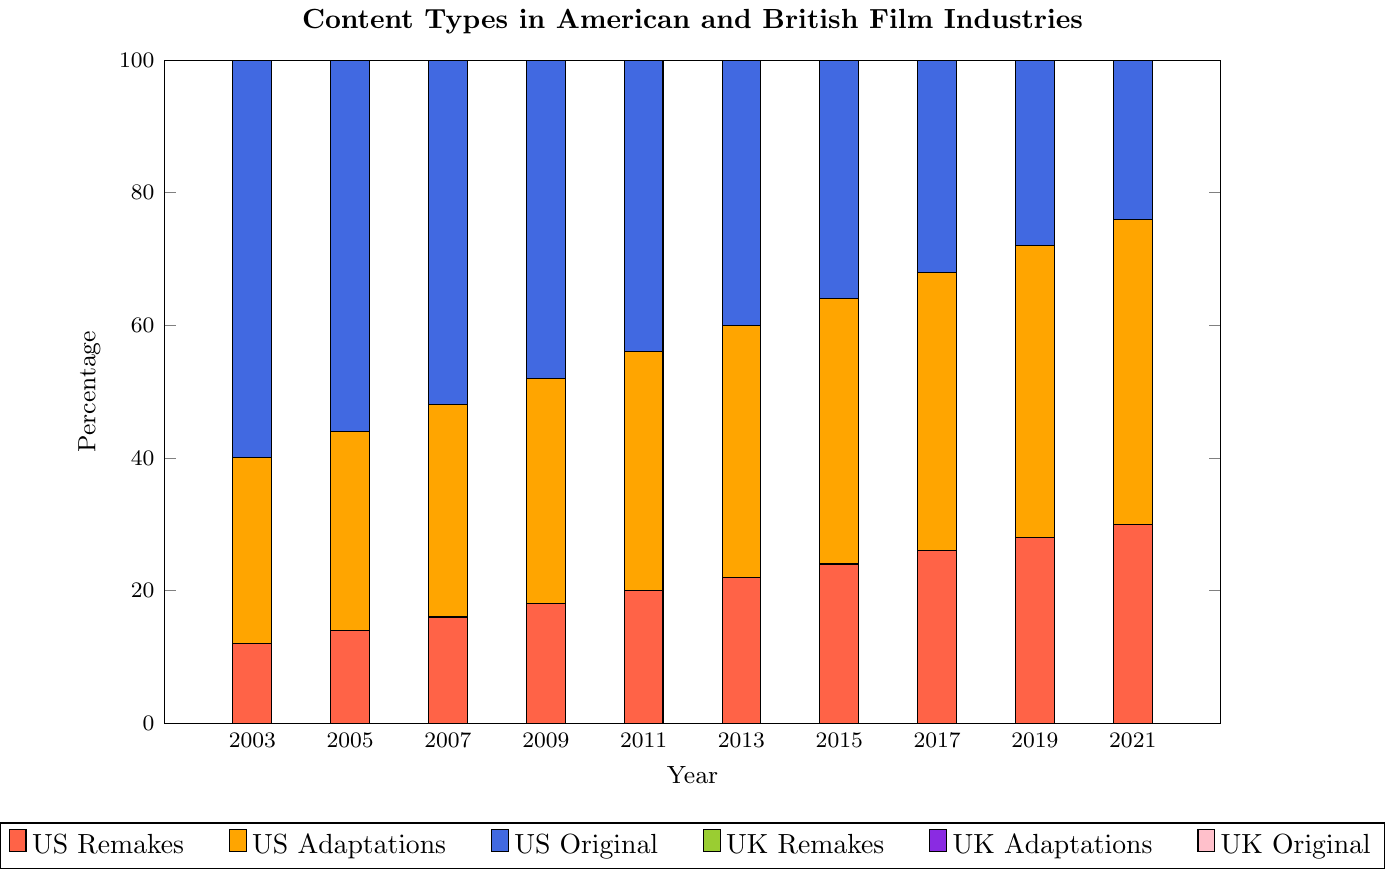What trend do you observe in the percentage of original content in the US film industry from 2003 to 2021? The percentage of original content in the US film industry shows a declining trend from 60% in 2003 to 24% in 2021. This indicates that US films are increasingly becoming adaptations or remakes over the years.
Answer: Declining trend from 60% to 24% How does the percentage of remakes in the UK film industry in 2021 compare to that in 2003? To compare the percentage of remakes in the UK film industry, observe that it is 8% in 2003 and 17% in 2021. This shows an increase in the percentage of remakes over the years.
Answer: Increased from 8% to 17% In which year did the US have the highest percentage of adaptations, and what was the percentage? To find the year with the highest percentage of adaptations for the US, we look at the years 2003 to 2021. The percentage of adaptations increases to a maximum of 46% in 2021.
Answer: 2021, 46% Compare the percentages of original content in the UK and the US film industries in 2013. In 2013, the percentage of original content in the US film industry is 40%, and in the UK, it is 55%. Thus, the UK has a higher percentage of original content than the US in that year.
Answer: UK: 55%, US: 40% What is the total percentage of remakes and adaptations combined in the UK film industry in 2017? To find the total percentage of remakes and adaptations in the UK film industry in 2017, add the percentages: remakes (15%) + adaptations (36%) = 51%.
Answer: 51% Is there a year where the percentage of remakes is equal in both the US and UK film industries? By comparing each year from 2003 to 2021, there is no year where the percentage of remakes is the same for both the US and UK film industries.
Answer: No By how much did the percentage of US original content decrease from 2003 to 2019? Calculate the difference in percentage of original content for the US from 2003 (60%) to 2019 (28%). The decrease is 60% - 28% = 32%.
Answer: 32% Which type of content (remakes, adaptations, or original) has the most significant change in percentage for the UK film industry over the given period? Analyze the change from 2003 to 2021: original content decreases from 70% to 43% (a reduction of 27%), remakes increase from 8% to 17% (an increase of 9%), and adaptations increase from 22% to 40% (an increase of 18%). The original content shows the most significant change with a 27% decrease.
Answer: Original content, 27% decrease 